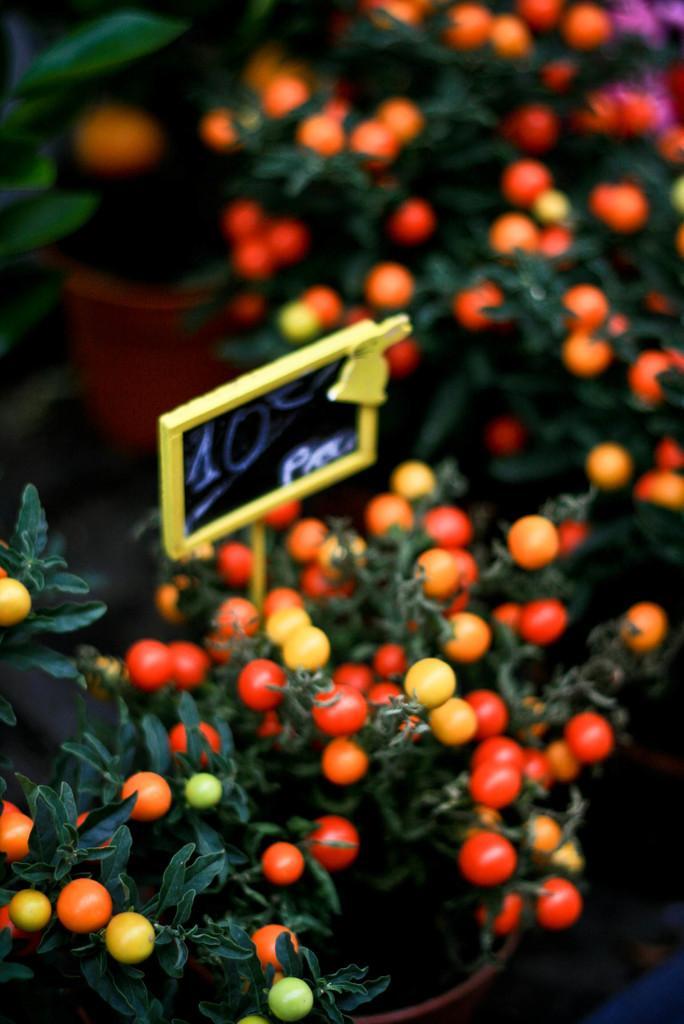Could you give a brief overview of what you see in this image? In this image we can see many plants. There are many plant pots in the image. There are many fruits to the plants. There is a board in the image. 